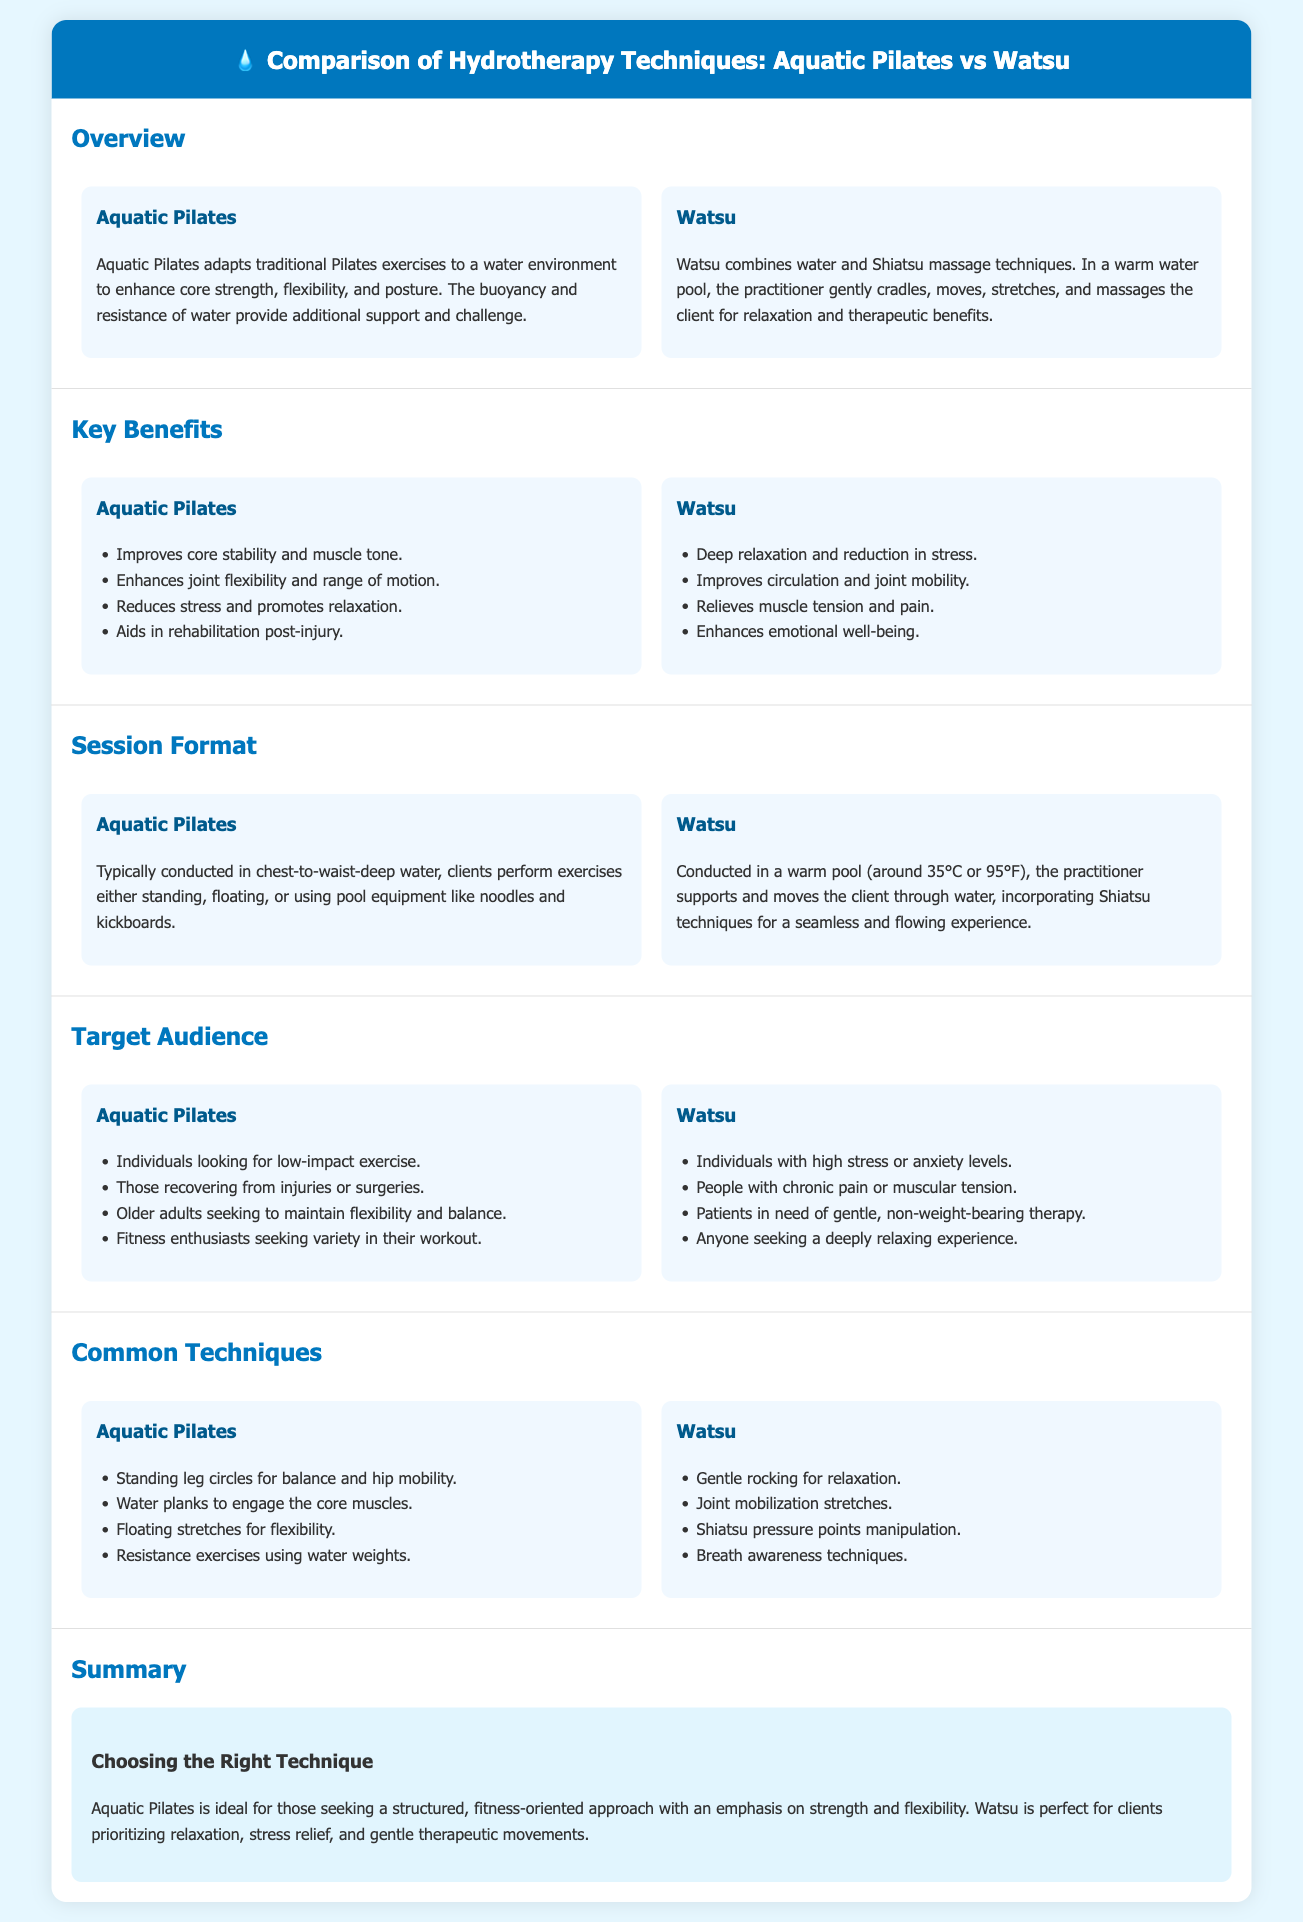what is the primary focus of Aquatic Pilates? Aquatic Pilates focuses on enhancing core strength, flexibility, and posture through exercises adapted to a water environment.
Answer: core strength, flexibility, posture what temperature is a Watsu session typically conducted at? Watsu sessions are conducted in a warm pool at around 35°C or 95°F.
Answer: 35°C or 95°F who is the target audience for Aquatic Pilates? The target audience for Aquatic Pilates includes individuals recovering from injuries or surgeries, and older adults seeking to maintain flexibility.
Answer: individuals recovering from injuries or surgeries, older adults list one key benefit of Watsu. One key benefit of Watsu is deep relaxation and reduction in stress.
Answer: deep relaxation and reduction in stress what session format does Aquatic Pilates typically use? Aquatic Pilates is typically conducted in chest-to-waist-deep water where clients perform exercises.
Answer: chest-to-waist-deep water which two techniques are common in Watsu? Common techniques in Watsu include gentle rocking and Shiatsu pressure points manipulation.
Answer: gentle rocking, Shiatsu pressure points manipulation what does Aquatic Pilates utilize for resistance during exercises? Aquatic Pilates utilizes pool equipment like noodles and kickboards for resistance during exercises.
Answer: pool equipment like noodles and kickboards what is the summary point for choosing between the two techniques? Aquatic Pilates is ideal for a structured fitness approach while Watsu is perfect for relaxation and stress relief.
Answer: structured fitness approach, relaxation, stress relief 